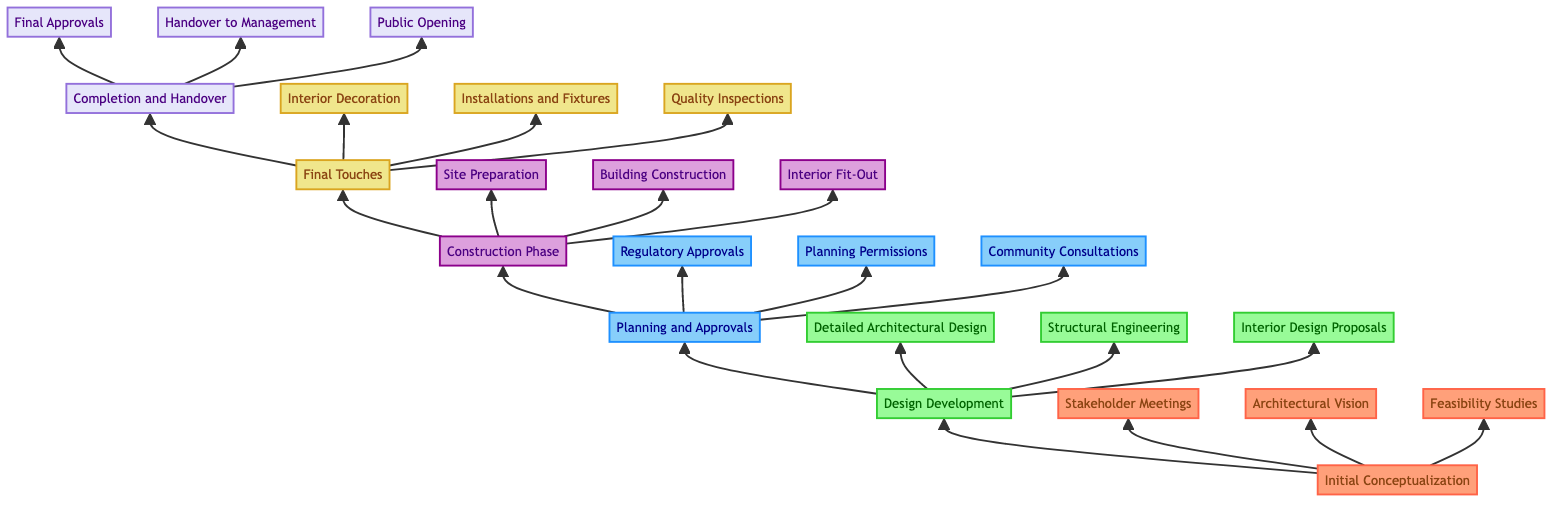What is the first step in the transformation process? The first element in the diagram is "Initial Conceptualization" as indicated by the bottom node of the chart.
Answer: Initial Conceptualization How many elements are in the final phase? "Completion and Handover" has three details listed beneath it: "Final Approvals", "Handover to Management", and "Public Opening".
Answer: 3 What phase comes after Design Development? The arrow from "Design Development" points directly to "Planning and Approvals", indicating the next phase in the process.
Answer: Planning and Approvals Which detailed task is associated with the Initial Conceptualization? The diagram shows three detailed tasks stemming from "Initial Conceptualization"; one of them is "Stakeholder Meetings".
Answer: Stakeholder Meetings Identify the last phase before project completion. The last phase before "Completion and Handover" is "Final Touches", which brings together various preparations for the project.
Answer: Final Touches What color represents the Design Development level? The diagram indicates that "Design Development" is colored light green, as shown by the defined class for that level.
Answer: Light green How many levels are there in the diagram? The diagram features a total of six levels, starting from "Initial Conceptualization" to "Completion and Handover".
Answer: 6 In which phase do quality inspections occur? "Quality Inspections" is listed under "Final Touches", which signifies it occurs after construction but before completion.
Answer: Final Touches What tasks are involved in the Construction Phase? The "Construction Phase" includes "Site Preparation", "Building Construction", and "Interior Fit-Out", as mentioned in the diagram.
Answer: Site Preparation, Building Construction, Interior Fit-Out 